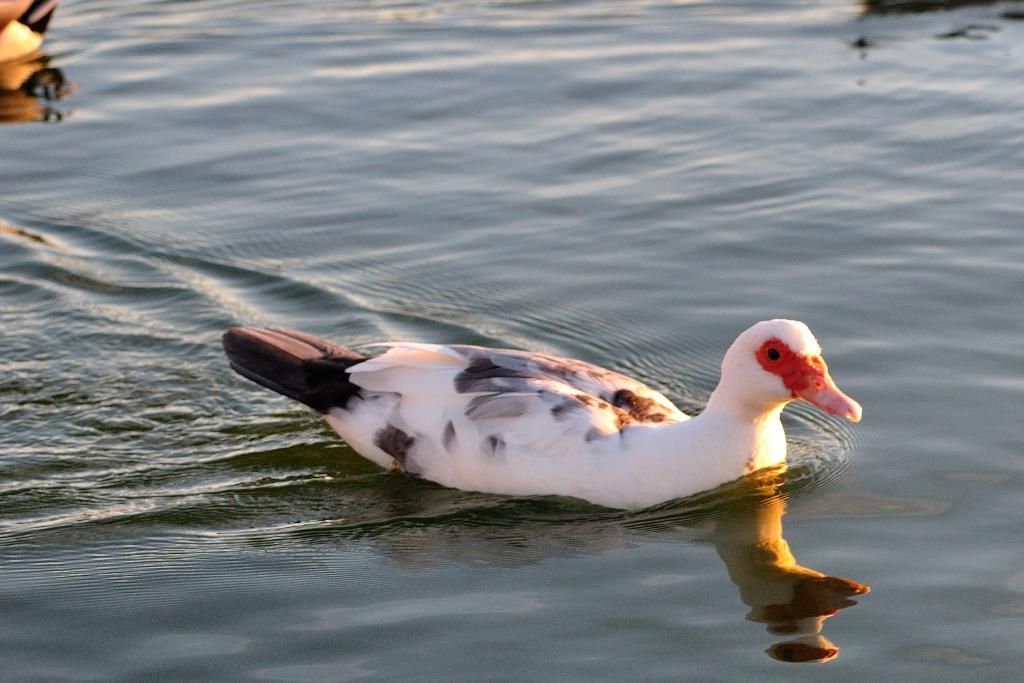What type of animal can be seen in the image? There is a bird in the image. What is the bird doing in the image? The bird is swimming in the water. Can you describe any other objects or elements in the water? There is an object floating on the water in the image. What time of day is it in the image, and how does the yam contribute to the scene? There is no yam present in the image, and the time of day cannot be determined from the image alone. 